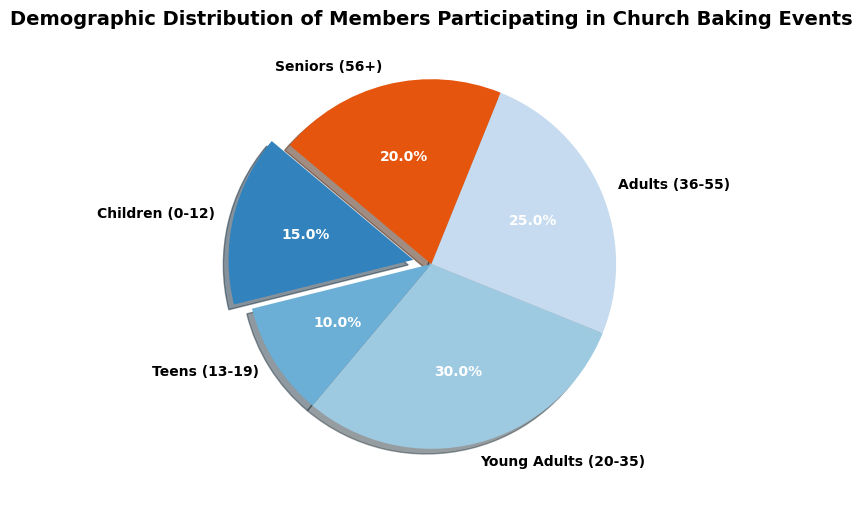Which age group has the highest percentage of participants? The slice with the largest size in the pie chart represents the age group with the highest percentage. This is the "Young Adults (20-35)" group, making up 30% of the participants.
Answer: Young Adults (20-35) What is the combined percentage of Adults and Seniors participating in the events? Adding the percentages of the "Adults (36-55)" group (25%) and the "Seniors (56+)" group (20%), the total is 25% + 20% = 45%.
Answer: 45% Which age group has the smallest percentage of participants? The slice with the smallest size in the pie chart represents the age group with the smallest percentage. This is the "Teens (13-19)" group, making up 10% of the participants.
Answer: Teens (13-19) How does the percentage of Children compare to that of Seniors? The percentage of Children (15%) is smaller than that of Seniors (20%).
Answer: Smaller What is the difference in participation percentage between Young Adults and Children? Subtracting the percentage of the "Children (0-12)" group (15%) from the "Young Adults (20-35)" group (30%), the difference is 30% - 15% = 15%.
Answer: 15% Are the total percentages of Children and Teens less than the percentage of Adults alone? Adding the percentages of the "Children (0-12)" group (15%) and the "Teens (13-19)" group (10%), the total is 15% + 10% = 25%. Comparing this to the "Adults (36-55)" group's 25%, they are equal.
Answer: No Which color is associated with the group having the second-highest percentage of participants? The "Adults (36-55)" group has the second-highest percentage (25%) and looking at the chart, the color of the slice for this group is identified. This color is typically associated visually with the second-largest slice.
Answer: Color associated with Adults (36-55) If the percentage of Teens were doubled, would they then have the highest percentage of participants? Doubling the percentage of the "Teens (13-19)" group from 10% to 20%, it would still be less than the highest percentage which is 30% by the "Young Adults (20-35)" group.
Answer: No 